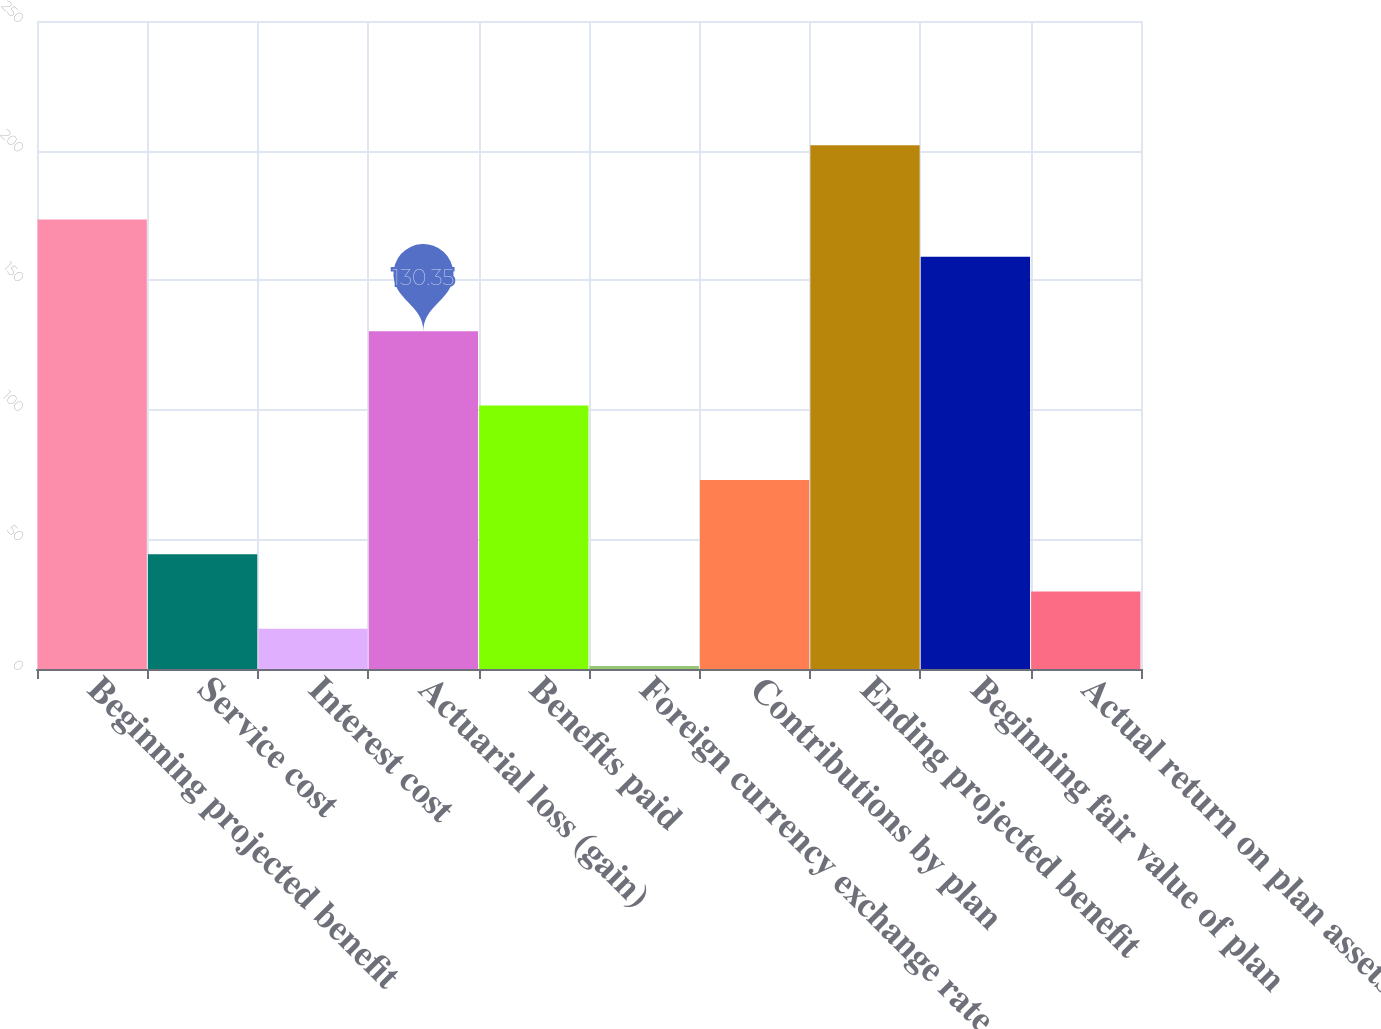Convert chart. <chart><loc_0><loc_0><loc_500><loc_500><bar_chart><fcel>Beginning projected benefit<fcel>Service cost<fcel>Interest cost<fcel>Actuarial loss (gain)<fcel>Benefits paid<fcel>Foreign currency exchange rate<fcel>Contributions by plan<fcel>Ending projected benefit<fcel>Beginning fair value of plan<fcel>Actual return on plan assets<nl><fcel>173.4<fcel>44.25<fcel>15.55<fcel>130.35<fcel>101.65<fcel>1.2<fcel>72.95<fcel>202.1<fcel>159.05<fcel>29.9<nl></chart> 